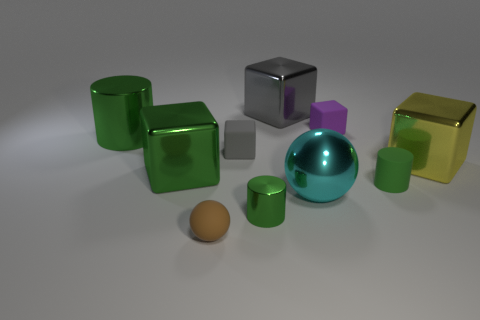There is a metal thing that is both on the right side of the big green metallic cube and behind the yellow metal thing; what is its shape?
Offer a very short reply. Cube. What color is the other matte object that is the same shape as the tiny purple rubber thing?
Your answer should be compact. Gray. How many things are either large shiny cubes behind the small purple cube or small cubes on the left side of the small purple block?
Provide a succinct answer. 2. The small brown thing has what shape?
Your answer should be compact. Sphere. What is the shape of the large thing that is the same color as the large metallic cylinder?
Your response must be concise. Cube. What number of green cylinders have the same material as the cyan thing?
Provide a short and direct response. 2. The tiny shiny thing has what color?
Your response must be concise. Green. The shiny thing that is the same size as the green matte cylinder is what color?
Your response must be concise. Green. Are there any tiny shiny cubes of the same color as the tiny matte cylinder?
Provide a succinct answer. No. There is a tiny green thing behind the large ball; does it have the same shape as the green metallic object behind the yellow shiny thing?
Provide a succinct answer. Yes. 